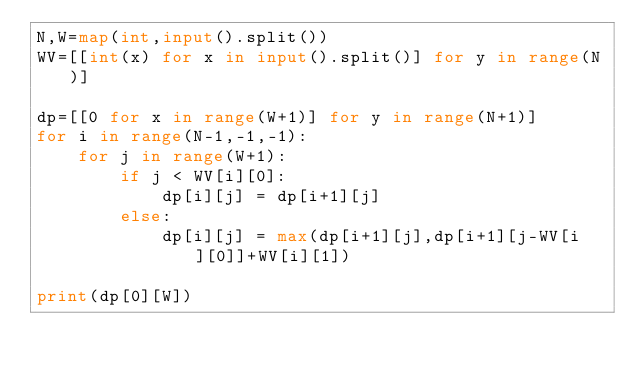<code> <loc_0><loc_0><loc_500><loc_500><_Python_>N,W=map(int,input().split())
WV=[[int(x) for x in input().split()] for y in range(N)]

dp=[[0 for x in range(W+1)] for y in range(N+1)]
for i in range(N-1,-1,-1):
    for j in range(W+1):
        if j < WV[i][0]:
            dp[i][j] = dp[i+1][j]
        else:
            dp[i][j] = max(dp[i+1][j],dp[i+1][j-WV[i][0]]+WV[i][1])

print(dp[0][W])</code> 